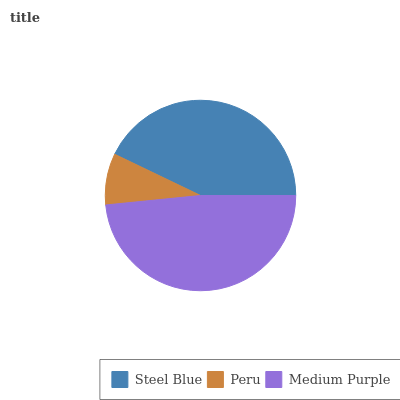Is Peru the minimum?
Answer yes or no. Yes. Is Medium Purple the maximum?
Answer yes or no. Yes. Is Medium Purple the minimum?
Answer yes or no. No. Is Peru the maximum?
Answer yes or no. No. Is Medium Purple greater than Peru?
Answer yes or no. Yes. Is Peru less than Medium Purple?
Answer yes or no. Yes. Is Peru greater than Medium Purple?
Answer yes or no. No. Is Medium Purple less than Peru?
Answer yes or no. No. Is Steel Blue the high median?
Answer yes or no. Yes. Is Steel Blue the low median?
Answer yes or no. Yes. Is Peru the high median?
Answer yes or no. No. Is Medium Purple the low median?
Answer yes or no. No. 